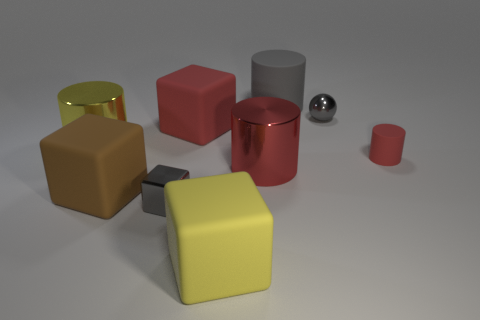Subtract all cylinders. How many objects are left? 5 Add 2 big brown rubber things. How many big brown rubber things exist? 3 Subtract 0 green cylinders. How many objects are left? 9 Subtract all red rubber things. Subtract all tiny gray balls. How many objects are left? 6 Add 5 yellow rubber cubes. How many yellow rubber cubes are left? 6 